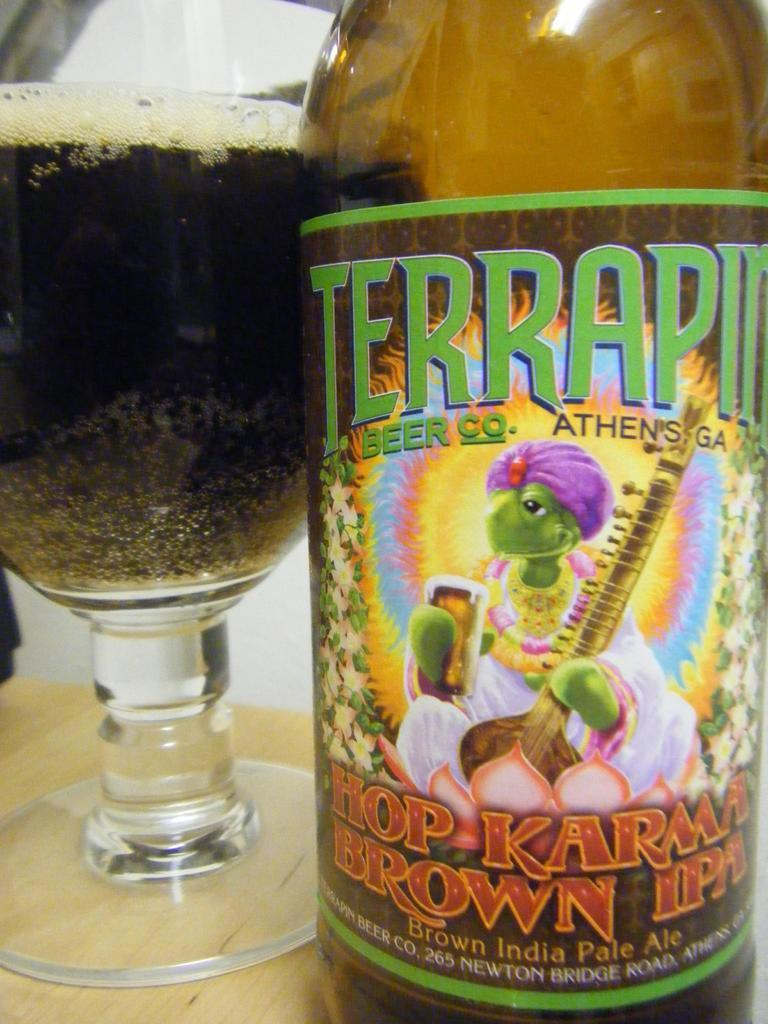What is present on the table in the image? There is a bottle and a glass on the table in the image. What material is the table made of? The table is made of wood. What type of knowledge is being shared between the bottle and the glass in the image? There is no indication in the image that the bottle and the glass are sharing any knowledge. 